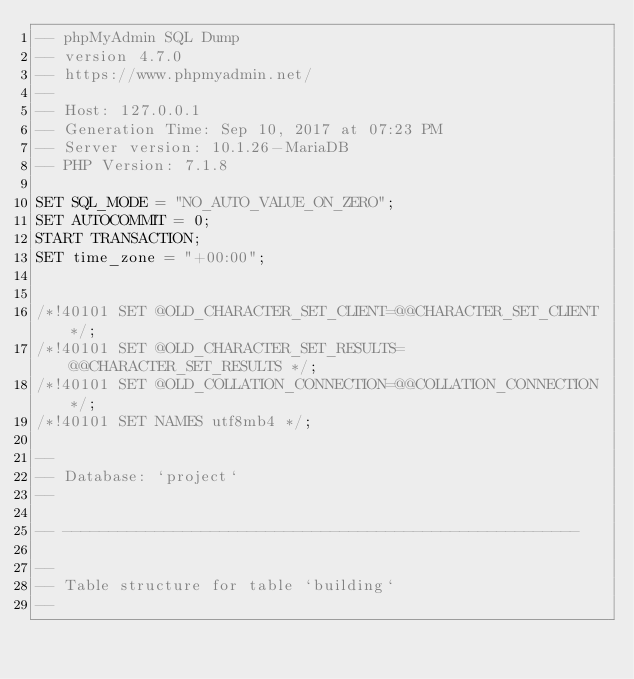<code> <loc_0><loc_0><loc_500><loc_500><_SQL_>-- phpMyAdmin SQL Dump
-- version 4.7.0
-- https://www.phpmyadmin.net/
--
-- Host: 127.0.0.1
-- Generation Time: Sep 10, 2017 at 07:23 PM
-- Server version: 10.1.26-MariaDB
-- PHP Version: 7.1.8

SET SQL_MODE = "NO_AUTO_VALUE_ON_ZERO";
SET AUTOCOMMIT = 0;
START TRANSACTION;
SET time_zone = "+00:00";


/*!40101 SET @OLD_CHARACTER_SET_CLIENT=@@CHARACTER_SET_CLIENT */;
/*!40101 SET @OLD_CHARACTER_SET_RESULTS=@@CHARACTER_SET_RESULTS */;
/*!40101 SET @OLD_COLLATION_CONNECTION=@@COLLATION_CONNECTION */;
/*!40101 SET NAMES utf8mb4 */;

--
-- Database: `project`
--

-- --------------------------------------------------------

--
-- Table structure for table `building`
--
</code> 